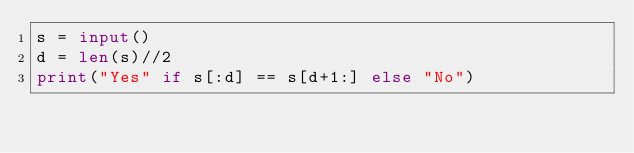Convert code to text. <code><loc_0><loc_0><loc_500><loc_500><_Python_>s = input()
d = len(s)//2
print("Yes" if s[:d] == s[d+1:] else "No")</code> 